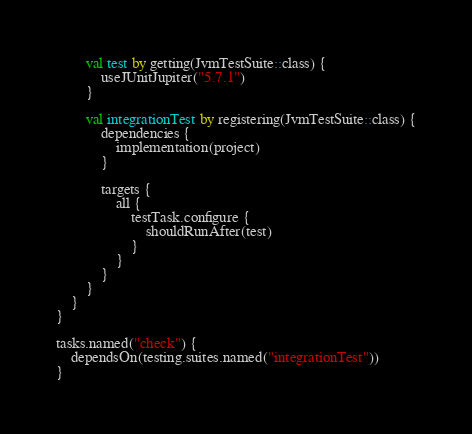Convert code to text. <code><loc_0><loc_0><loc_500><loc_500><_Kotlin_>        val test by getting(JvmTestSuite::class) {
            useJUnitJupiter("5.7.1")
        }

        val integrationTest by registering(JvmTestSuite::class) {
            dependencies {
                implementation(project)
            }

            targets {
                all {
                    testTask.configure {
                        shouldRunAfter(test)
                    }
                }
            }
        }
    }
}

tasks.named("check") {
    dependsOn(testing.suites.named("integrationTest"))
}
</code> 